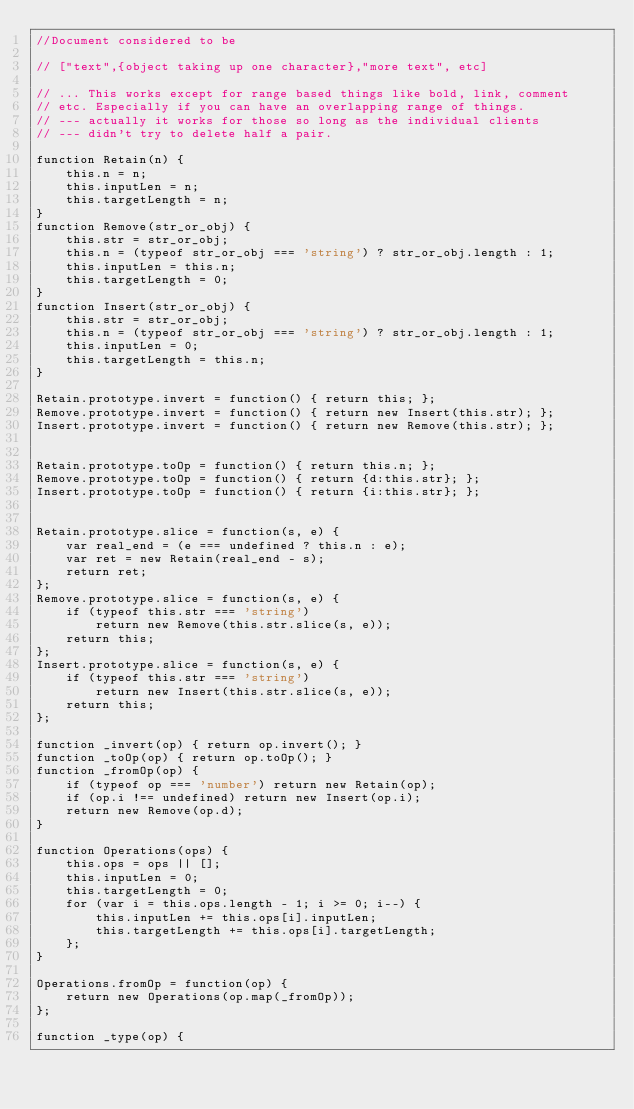Convert code to text. <code><loc_0><loc_0><loc_500><loc_500><_JavaScript_>//Document considered to be

// ["text",{object taking up one character},"more text", etc]

// ... This works except for range based things like bold, link, comment
// etc. Especially if you can have an overlapping range of things.
// --- actually it works for those so long as the individual clients
// --- didn't try to delete half a pair.

function Retain(n) {
	this.n = n;
	this.inputLen = n;
	this.targetLength = n;
}
function Remove(str_or_obj) {
	this.str = str_or_obj;
	this.n = (typeof str_or_obj === 'string') ? str_or_obj.length : 1;
	this.inputLen = this.n;
	this.targetLength = 0;
}
function Insert(str_or_obj) {
	this.str = str_or_obj;
	this.n = (typeof str_or_obj === 'string') ? str_or_obj.length : 1;
	this.inputLen = 0;
	this.targetLength = this.n;
}

Retain.prototype.invert = function() { return this; };
Remove.prototype.invert = function() { return new Insert(this.str); };
Insert.prototype.invert = function() { return new Remove(this.str); };


Retain.prototype.toOp = function() { return this.n; };
Remove.prototype.toOp = function() { return {d:this.str}; };
Insert.prototype.toOp = function() { return {i:this.str}; };


Retain.prototype.slice = function(s, e) {
	var real_end = (e === undefined ? this.n : e);
	var ret = new Retain(real_end - s);
	return ret;
};
Remove.prototype.slice = function(s, e) {
	if (typeof this.str === 'string')
		return new Remove(this.str.slice(s, e));
	return this;
};
Insert.prototype.slice = function(s, e) {
	if (typeof this.str === 'string')
		return new Insert(this.str.slice(s, e));
	return this;
};

function _invert(op) { return op.invert(); }
function _toOp(op) { return op.toOp(); }
function _fromOp(op) {
	if (typeof op === 'number') return new Retain(op);
	if (op.i !== undefined) return new Insert(op.i);
	return new Remove(op.d);
}

function Operations(ops) {
	this.ops = ops || [];
	this.inputLen = 0;
	this.targetLength = 0;
	for (var i = this.ops.length - 1; i >= 0; i--) {
		this.inputLen += this.ops[i].inputLen;
		this.targetLength += this.ops[i].targetLength;
	};
}

Operations.fromOp = function(op) {
	return new Operations(op.map(_fromOp));
};

function _type(op) {</code> 